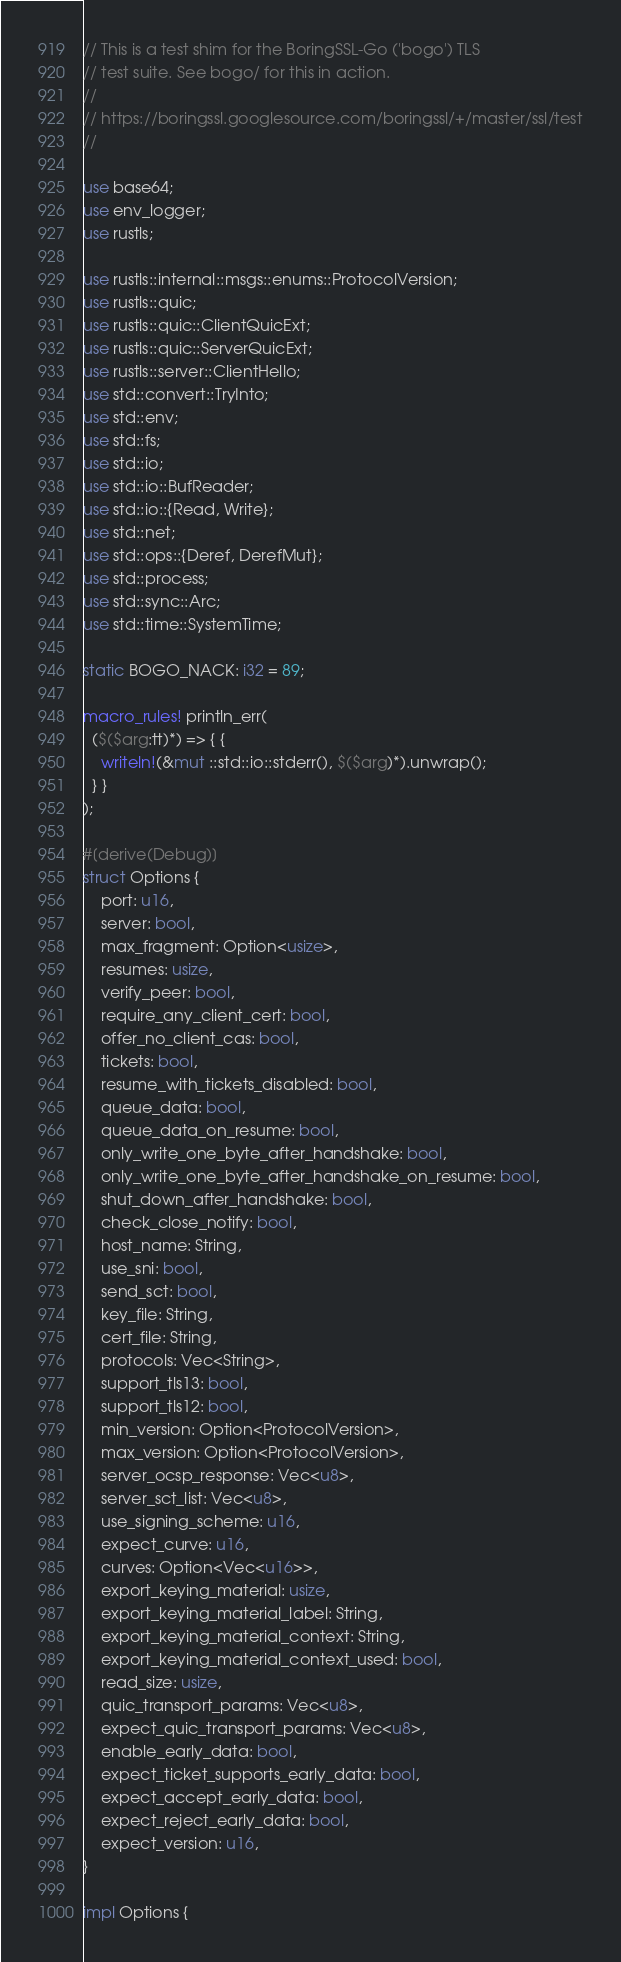Convert code to text. <code><loc_0><loc_0><loc_500><loc_500><_Rust_>// This is a test shim for the BoringSSL-Go ('bogo') TLS
// test suite. See bogo/ for this in action.
//
// https://boringssl.googlesource.com/boringssl/+/master/ssl/test
//

use base64;
use env_logger;
use rustls;

use rustls::internal::msgs::enums::ProtocolVersion;
use rustls::quic;
use rustls::quic::ClientQuicExt;
use rustls::quic::ServerQuicExt;
use rustls::server::ClientHello;
use std::convert::TryInto;
use std::env;
use std::fs;
use std::io;
use std::io::BufReader;
use std::io::{Read, Write};
use std::net;
use std::ops::{Deref, DerefMut};
use std::process;
use std::sync::Arc;
use std::time::SystemTime;

static BOGO_NACK: i32 = 89;

macro_rules! println_err(
  ($($arg:tt)*) => { {
    writeln!(&mut ::std::io::stderr(), $($arg)*).unwrap();
  } }
);

#[derive(Debug)]
struct Options {
    port: u16,
    server: bool,
    max_fragment: Option<usize>,
    resumes: usize,
    verify_peer: bool,
    require_any_client_cert: bool,
    offer_no_client_cas: bool,
    tickets: bool,
    resume_with_tickets_disabled: bool,
    queue_data: bool,
    queue_data_on_resume: bool,
    only_write_one_byte_after_handshake: bool,
    only_write_one_byte_after_handshake_on_resume: bool,
    shut_down_after_handshake: bool,
    check_close_notify: bool,
    host_name: String,
    use_sni: bool,
    send_sct: bool,
    key_file: String,
    cert_file: String,
    protocols: Vec<String>,
    support_tls13: bool,
    support_tls12: bool,
    min_version: Option<ProtocolVersion>,
    max_version: Option<ProtocolVersion>,
    server_ocsp_response: Vec<u8>,
    server_sct_list: Vec<u8>,
    use_signing_scheme: u16,
    expect_curve: u16,
    curves: Option<Vec<u16>>,
    export_keying_material: usize,
    export_keying_material_label: String,
    export_keying_material_context: String,
    export_keying_material_context_used: bool,
    read_size: usize,
    quic_transport_params: Vec<u8>,
    expect_quic_transport_params: Vec<u8>,
    enable_early_data: bool,
    expect_ticket_supports_early_data: bool,
    expect_accept_early_data: bool,
    expect_reject_early_data: bool,
    expect_version: u16,
}

impl Options {</code> 